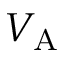Convert formula to latex. <formula><loc_0><loc_0><loc_500><loc_500>V _ { A }</formula> 